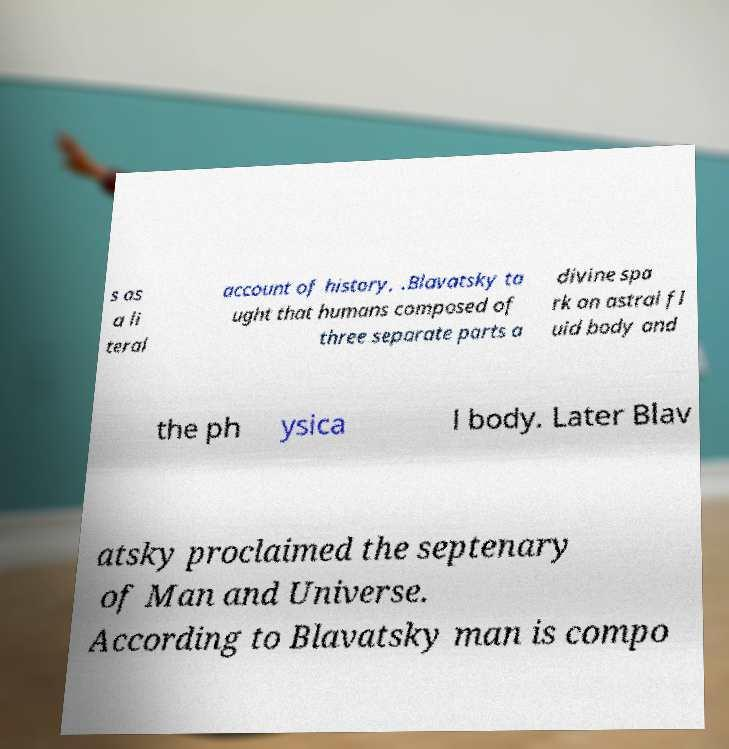Can you accurately transcribe the text from the provided image for me? s as a li teral account of history, .Blavatsky ta ught that humans composed of three separate parts a divine spa rk an astral fl uid body and the ph ysica l body. Later Blav atsky proclaimed the septenary of Man and Universe. According to Blavatsky man is compo 